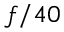Convert formula to latex. <formula><loc_0><loc_0><loc_500><loc_500>f / 4 0</formula> 